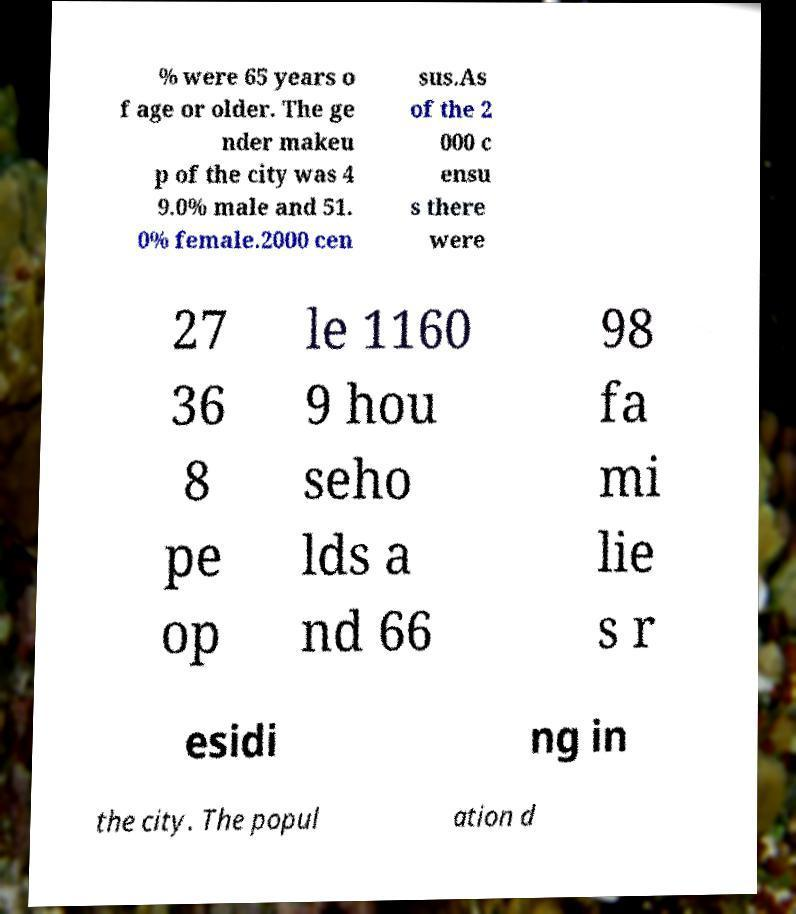Please identify and transcribe the text found in this image. % were 65 years o f age or older. The ge nder makeu p of the city was 4 9.0% male and 51. 0% female.2000 cen sus.As of the 2 000 c ensu s there were 27 36 8 pe op le 1160 9 hou seho lds a nd 66 98 fa mi lie s r esidi ng in the city. The popul ation d 